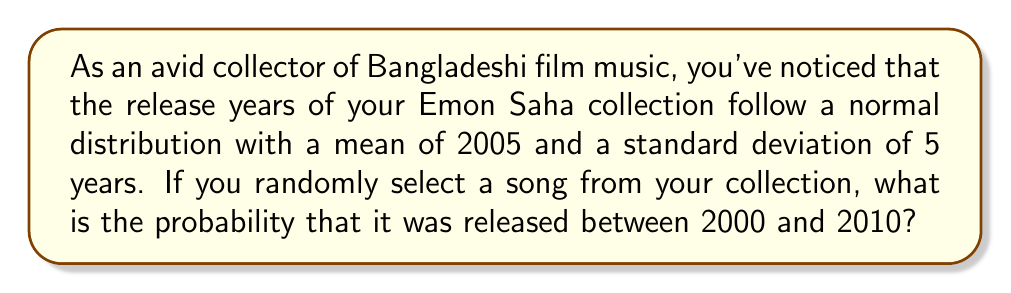Can you answer this question? Let's approach this step-by-step:

1) The release years follow a normal distribution with:
   $\mu = 2005$ (mean)
   $\sigma = 5$ (standard deviation)

2) We need to find $P(2000 \leq X \leq 2010)$, where $X$ is the release year.

3) To use the standard normal distribution, we need to standardize these values:
   For 2000: $z_1 = \frac{2000 - 2005}{5} = -1$
   For 2010: $z_2 = \frac{2010 - 2005}{5} = 1$

4) Now we need to find $P(-1 \leq Z \leq 1)$, where $Z$ is the standard normal variable.

5) Using the standard normal distribution table or calculator:
   $P(Z \leq 1) = 0.8413$
   $P(Z \leq -1) = 0.1587$

6) The probability we're looking for is:
   $P(-1 \leq Z \leq 1) = P(Z \leq 1) - P(Z \leq -1)$
   $= 0.8413 - 0.1587 = 0.6826$

Therefore, the probability that a randomly selected song from your Emon Saha collection was released between 2000 and 2010 is approximately 0.6826 or 68.26%.
Answer: 0.6826 